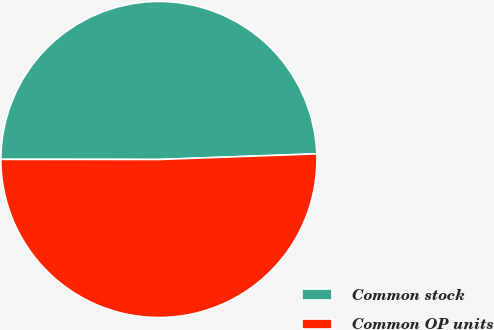Convert chart to OTSL. <chart><loc_0><loc_0><loc_500><loc_500><pie_chart><fcel>Common stock<fcel>Common OP units<nl><fcel>49.42%<fcel>50.58%<nl></chart> 